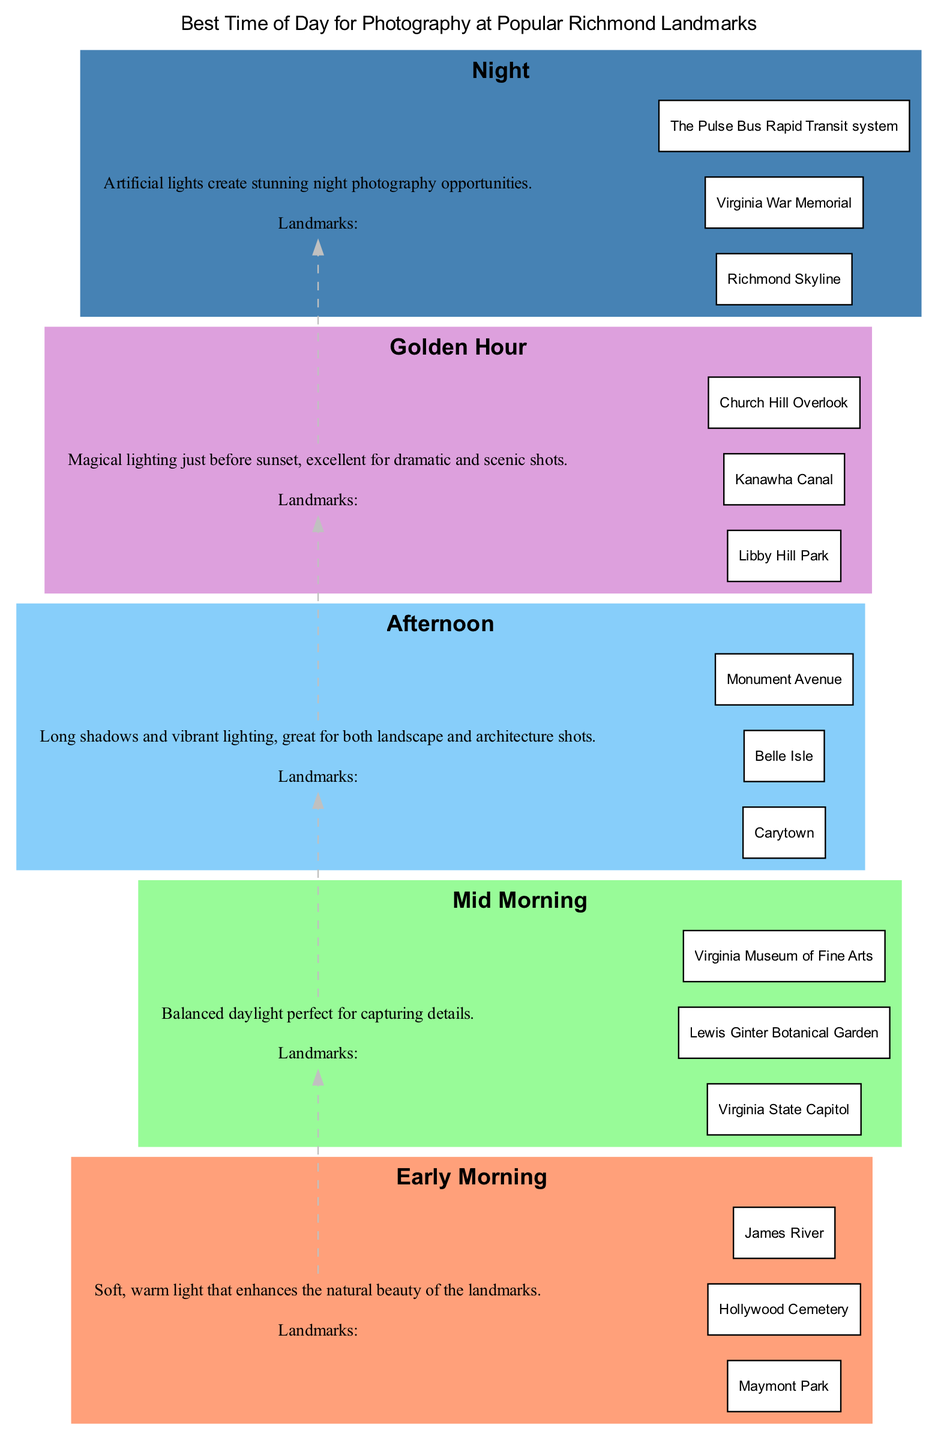What landmarks are suggested for early morning photography? The diagram specifies that the landmarks for early morning photography are Maymont Park, Hollywood Cemetery, and James River.
Answer: Maymont Park, Hollywood Cemetery, James River What time of day is ideal for capturing details of landmarks? The pathway indicates that mid morning is the best time for capturing details, as it provides balanced daylight.
Answer: Mid morning How many landmarks are listed for the golden hour? The diagram lists three landmarks specifically for golden hour photography: Libby Hill Park, Kanawha Canal, and Church Hill Overlook.
Answer: Three What is the description for afternoon photography? According to the diagram, afternoon photography is characterized by long shadows and vibrant lighting, which is great for both landscape and architecture shots.
Answer: Long shadows and vibrant lighting Which time has landmarks that are great for night photography? Night photography landmarks are mentioned in the pathway as Richmond Skyline, Virginia War Memorial, and The Pulse Bus Rapid Transit system.
Answer: Richmond Skyline, Virginia War Memorial, The Pulse Bus Rapid Transit system Which two times are consecutively related according to the pathway? The pathway shows a dashed edge from early morning to mid morning, indicating a flow from the first to the second time of day.
Answer: Early morning and mid morning What is the common feature of landmarks suggested for golden hour photography? The common feature highlighted for golden hour photography is the magical lighting just before sunset, which is excellent for dramatic and scenic shots.
Answer: Magical lighting just before sunset What color is used to represent afternoon in the diagram? The pathway uses the color light blue for the afternoon section, which corresponds to the time of day for photography.
Answer: Light blue How many unique times of day are indicated in the pathway? The diagram depicts five unique times of day for photography: early morning, mid morning, afternoon, golden hour, and night.
Answer: Five 